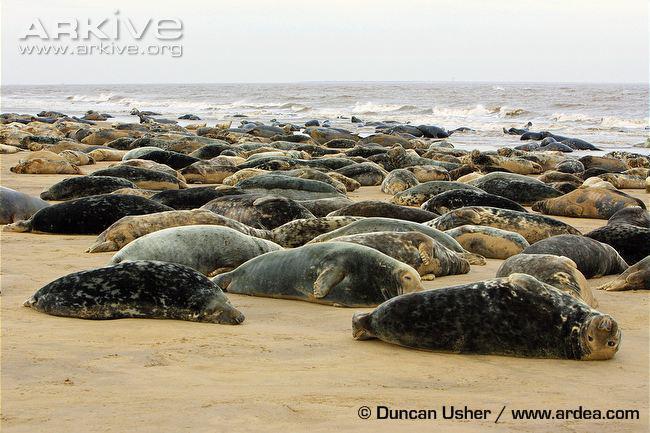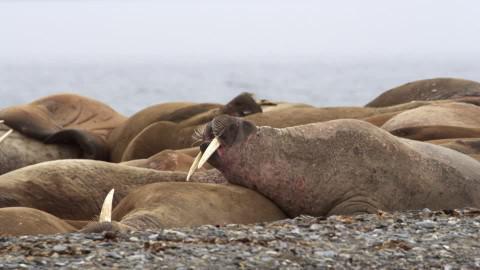The first image is the image on the left, the second image is the image on the right. For the images displayed, is the sentence "None of the pictures have more than two seals in them." factually correct? Answer yes or no. No. The first image is the image on the left, the second image is the image on the right. For the images displayed, is the sentence "Each image includes a seal with upright head and shoulders, and no seals are in the water." factually correct? Answer yes or no. No. 